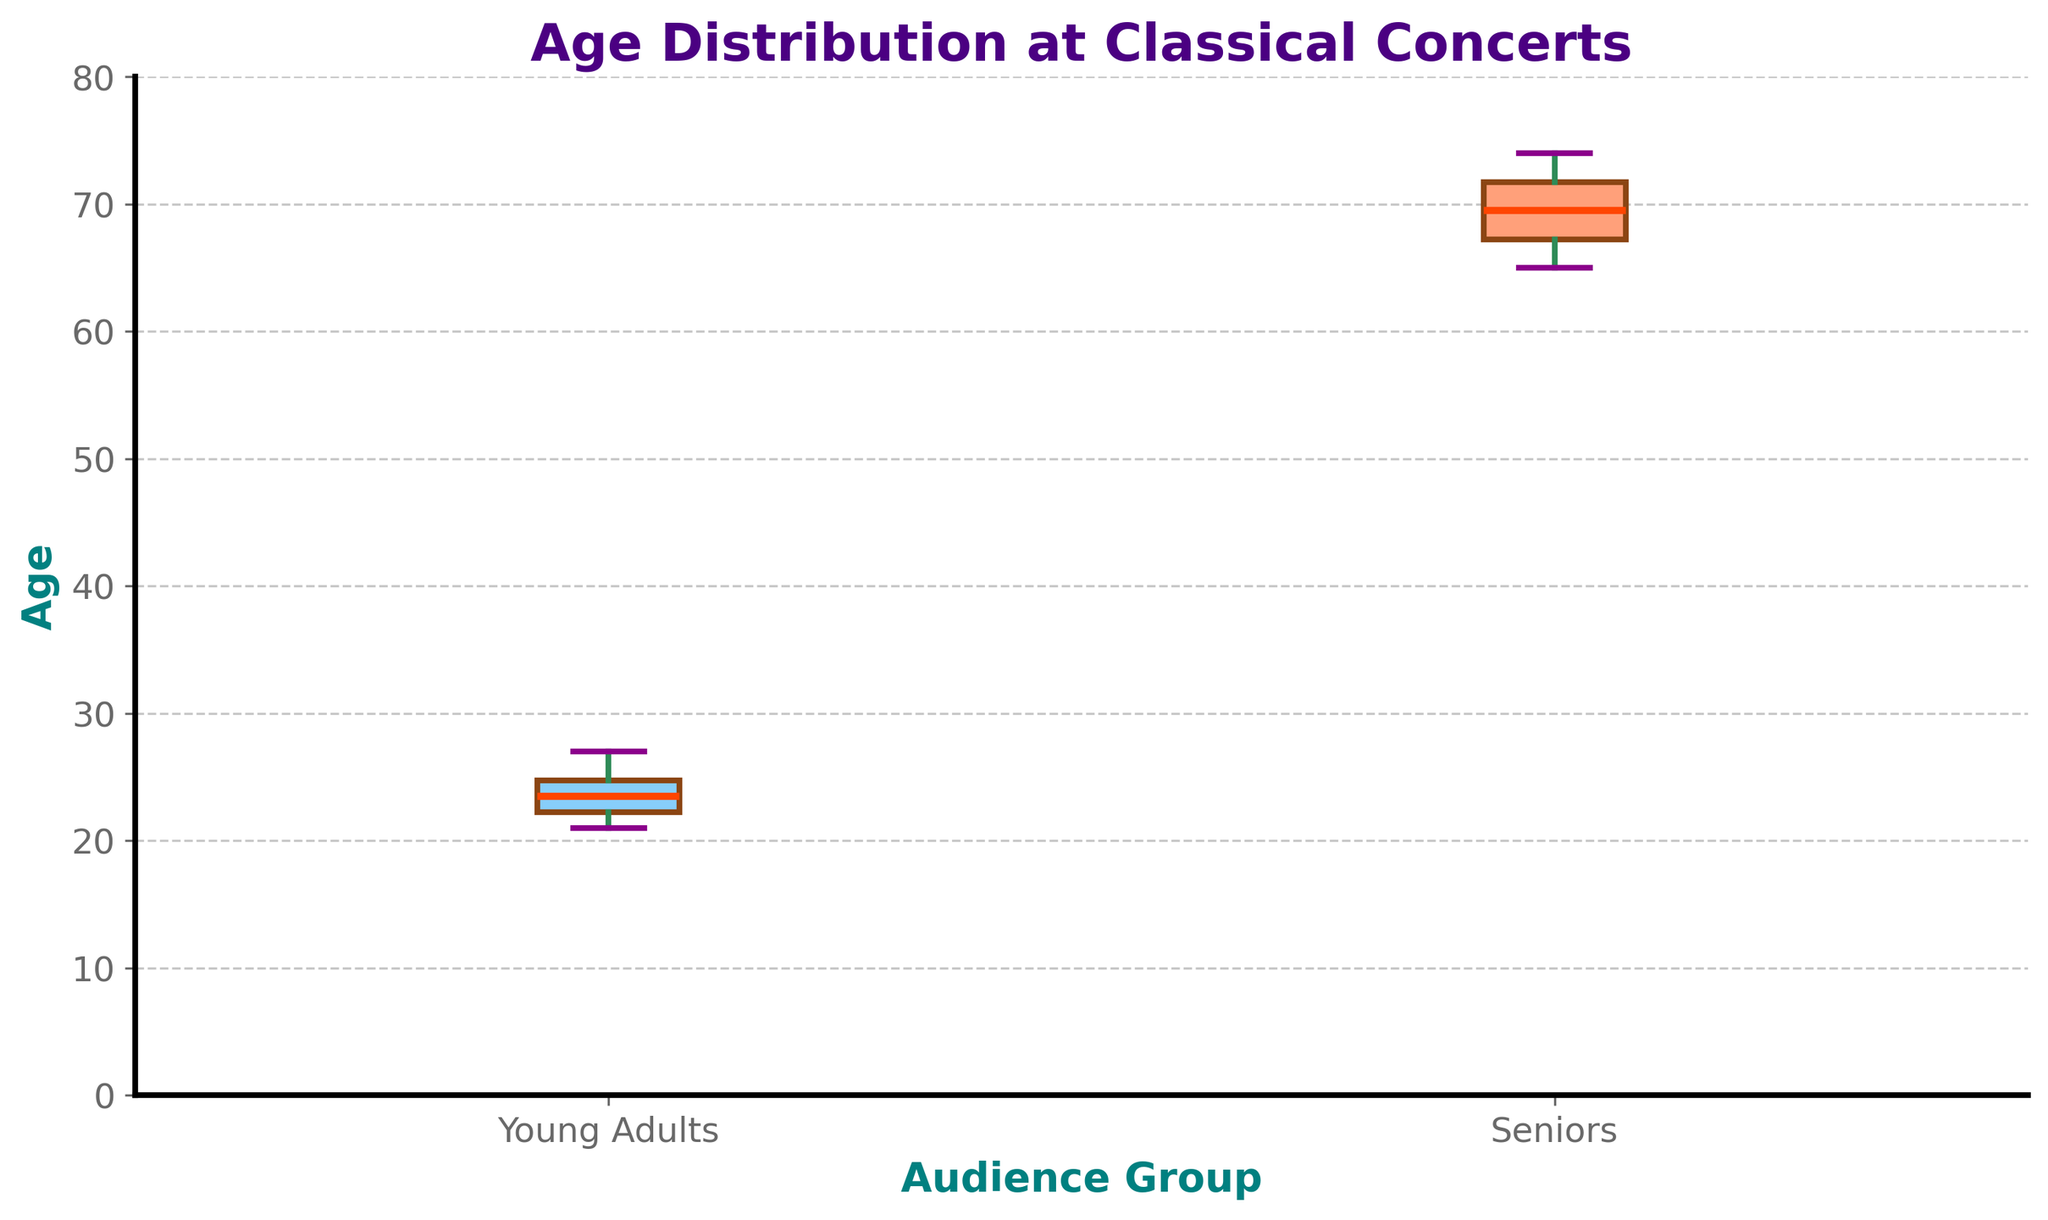What is the title of the plot? The title of the plot appears at the top and reads "Age Distribution at Classical Concerts". This helps to understand the main subject of the visual representation.
Answer: Age Distribution at Classical Concerts What is the median age of the Young Adults group? The median age is indicated by the line inside the box of the Young Adults group. In the visualization, this line is at age 24.
Answer: 24 Which group has a greater interquartile range (IQR)? The IQR is represented by the length of the box (the distance between the first quartile and the third quartile). In the figure, the Seniors group has a visibly larger box compared to the Young Adults group, indicating a greater IQR.
Answer: Seniors What are the whisker ranges for the Young Adults group? Whiskers extend from the box to the smallest and largest values within 1.5 times the IQR from the quartiles. For the Young Adults group, the lower whisker extends to 21, and the upper whisker extends to 27.
Answer: 21 to 27 Which group's data has more variability? The variability in data is higher if the whiskers and the box occupy a larger range of values. Observing the plot, the Seniors group has a wider spread of whiskers and box, indicating more variability.
Answer: Seniors What do the dots in the plot represent? Dots outside the whiskers are outliers, values that lie beyond 1.5 times the IQR from the quartiles.
Answer: Outliers What is the color of the box for the Seniors group? The box for the Seniors group is colored in a light orange shade.
Answer: Light orange What is the maximum age observed in the Young Adults group? The maximum age in the Young Adults group is indicated by the top of the upper whisker, which extends to 27.
Answer: 27 How does the median age of Seniors compare to that of Young Adults? The median age for the Seniors group is higher than that of Young Adults. The line inside the Seniors' box is at 70, whereas for Young Adults it is 24.
Answer: The median age for Seniors is higher What is the typical age range for most Young Adults attending classical concerts? The typical age range is represented by the box (25th to 75th percentile). For the Young Adults, this box spans from approximately 22 to 25 years old.
Answer: 22 to 25 